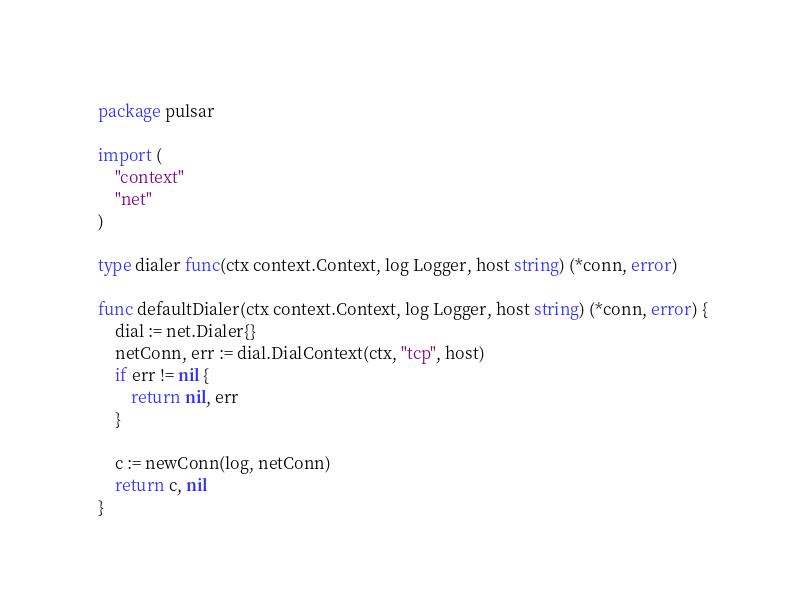<code> <loc_0><loc_0><loc_500><loc_500><_Go_>package pulsar

import (
	"context"
	"net"
)

type dialer func(ctx context.Context, log Logger, host string) (*conn, error)

func defaultDialer(ctx context.Context, log Logger, host string) (*conn, error) {
	dial := net.Dialer{}
	netConn, err := dial.DialContext(ctx, "tcp", host)
	if err != nil {
		return nil, err
	}

	c := newConn(log, netConn)
	return c, nil
}
</code> 